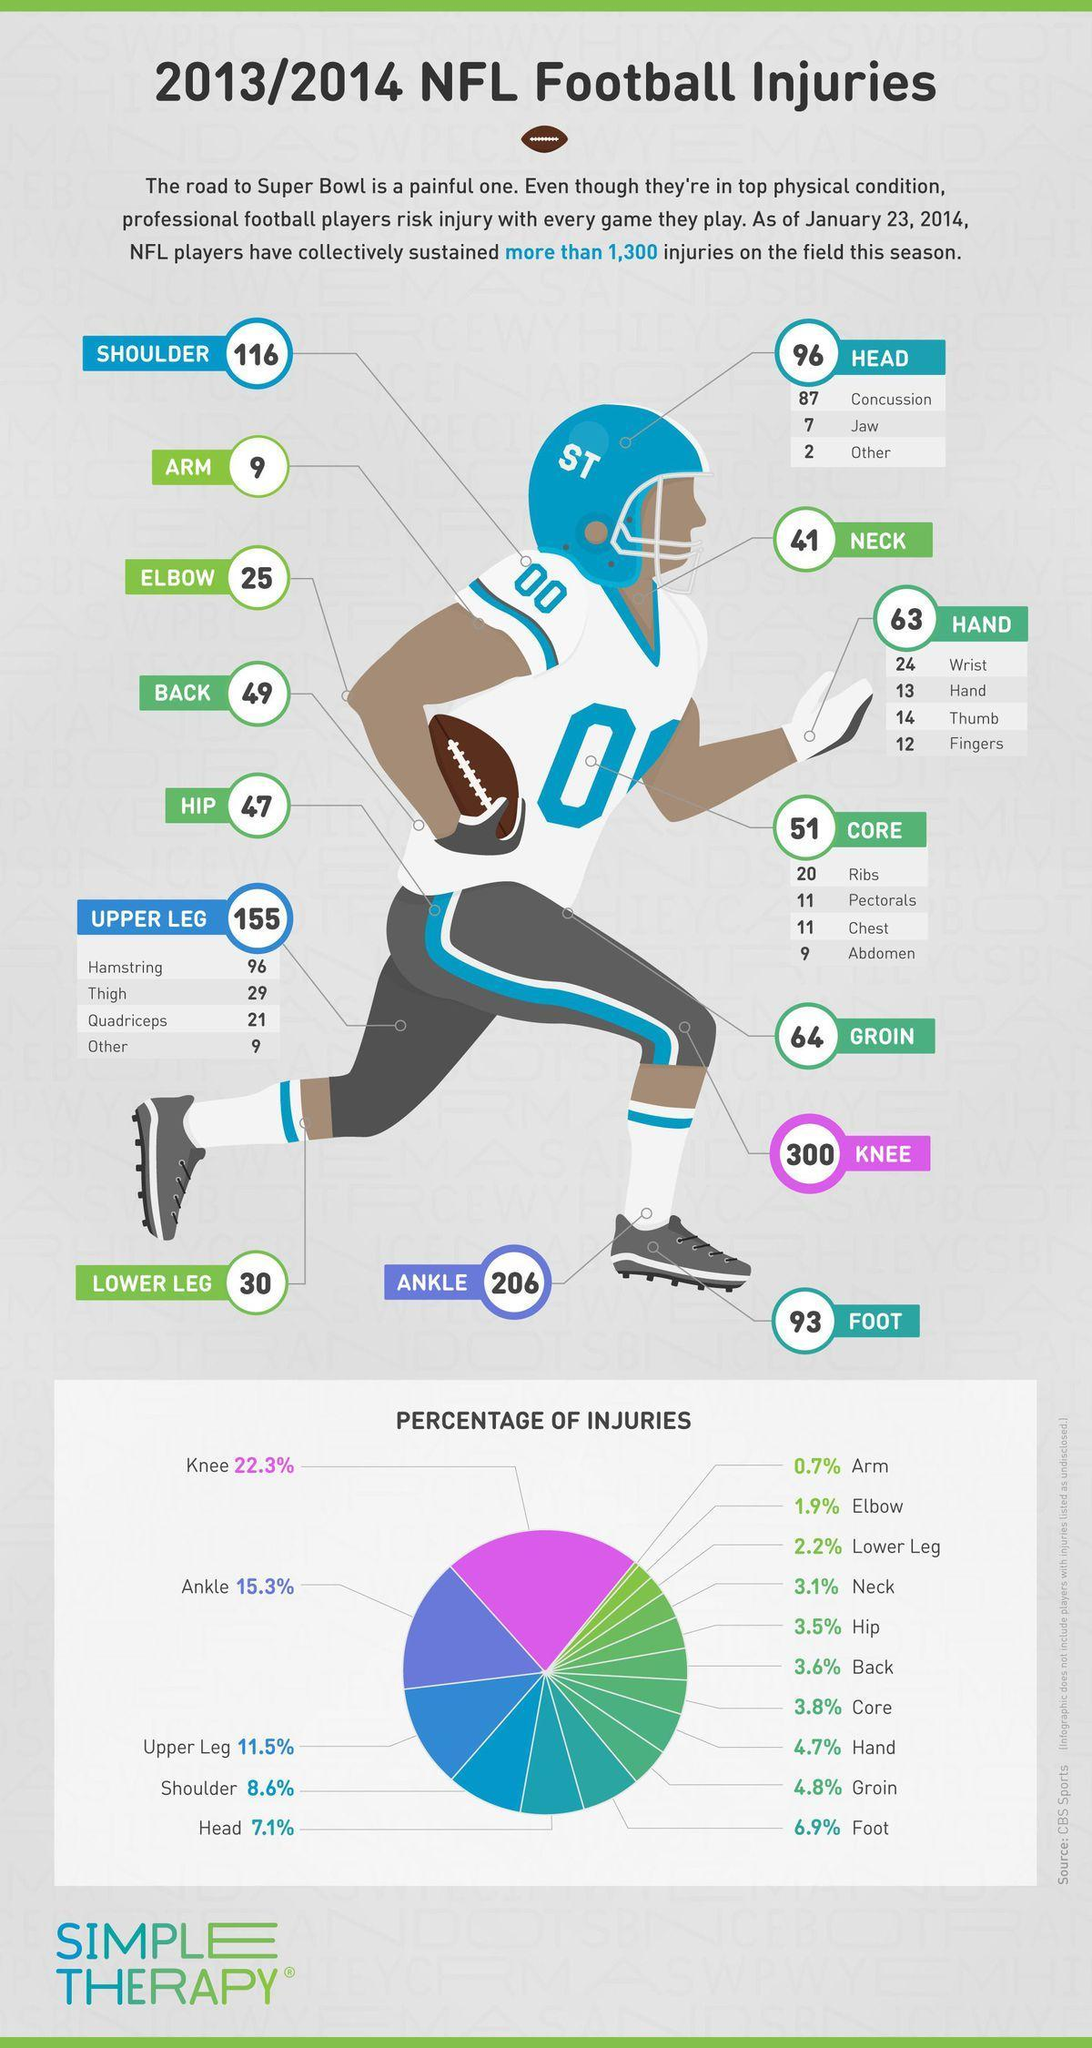Which part gets most injured among the respondents?
Answer the question with a short phrase. Knee What percent of injuries occur from knee downwards including knee? 46.7% What colour is the helmet of the player shown-blue, yellow or red? blue What percent of injuries are from neck upwards? 10.2% 